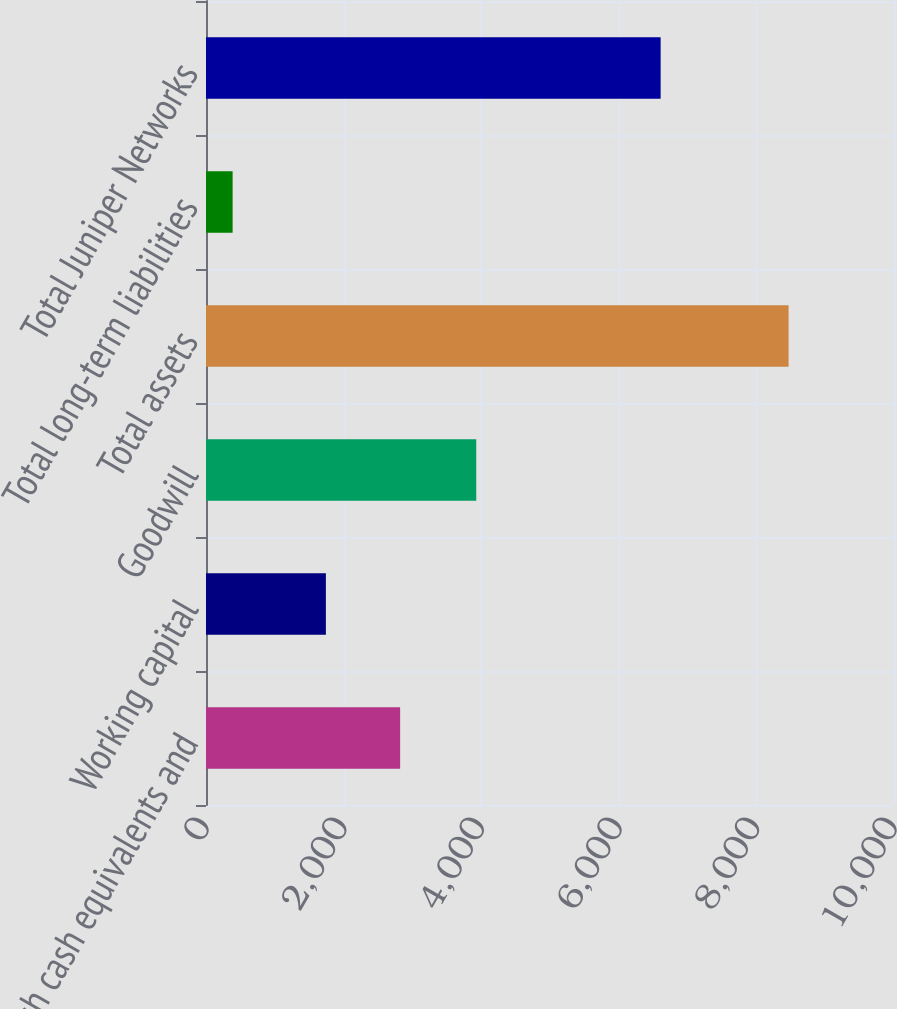Convert chart. <chart><loc_0><loc_0><loc_500><loc_500><bar_chart><fcel>Cash cash equivalents and<fcel>Working capital<fcel>Goodwill<fcel>Total assets<fcel>Total long-term liabilities<fcel>Total Juniper Networks<nl><fcel>2821.6<fcel>1742.4<fcel>3927.8<fcel>8467.9<fcel>387.1<fcel>6608.2<nl></chart> 